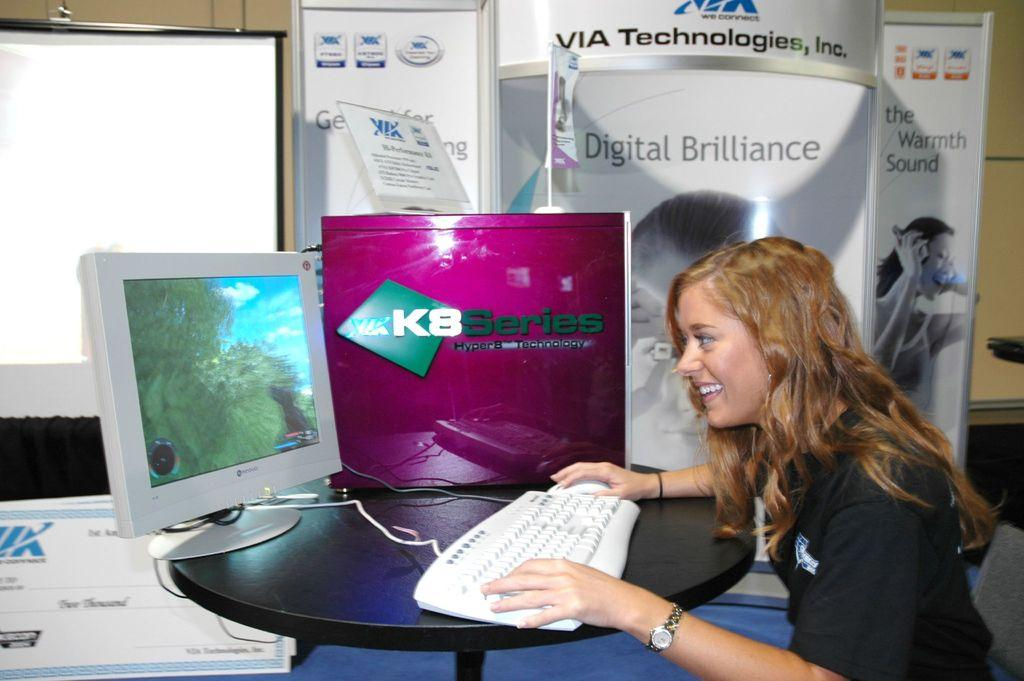<image>
Relay a brief, clear account of the picture shown. Store displays advertise products from Via Technologies, Inc. 